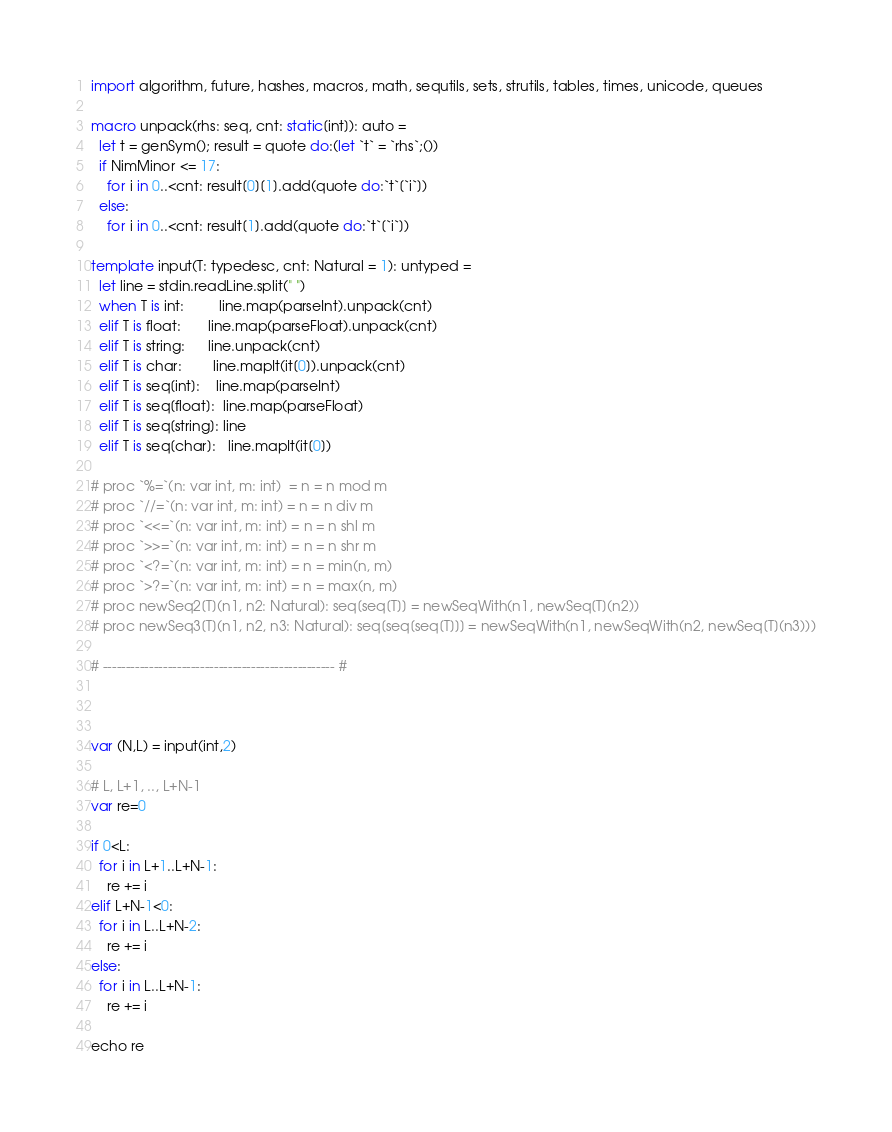Convert code to text. <code><loc_0><loc_0><loc_500><loc_500><_Nim_>import algorithm, future, hashes, macros, math, sequtils, sets, strutils, tables, times, unicode, queues
 
macro unpack(rhs: seq, cnt: static[int]): auto =
  let t = genSym(); result = quote do:(let `t` = `rhs`;())
  if NimMinor <= 17:
    for i in 0..<cnt: result[0][1].add(quote do:`t`[`i`])
  else:
    for i in 0..<cnt: result[1].add(quote do:`t`[`i`])
 
template input(T: typedesc, cnt: Natural = 1): untyped =
  let line = stdin.readLine.split(" ")
  when T is int:         line.map(parseInt).unpack(cnt)
  elif T is float:       line.map(parseFloat).unpack(cnt)
  elif T is string:      line.unpack(cnt)
  elif T is char:        line.mapIt(it[0]).unpack(cnt)
  elif T is seq[int]:    line.map(parseInt)
  elif T is seq[float]:  line.map(parseFloat)
  elif T is seq[string]: line
  elif T is seq[char]:   line.mapIt(it[0])
 
# proc `%=`(n: var int, m: int)  = n = n mod m
# proc `//=`(n: var int, m: int) = n = n div m
# proc `<<=`(n: var int, m: int) = n = n shl m
# proc `>>=`(n: var int, m: int) = n = n shr m
# proc `<?=`(n: var int, m: int) = n = min(n, m)
# proc `>?=`(n: var int, m: int) = n = max(n, m)
# proc newSeq2[T](n1, n2: Natural): seq[seq[T]] = newSeqWith(n1, newSeq[T](n2))
# proc newSeq3[T](n1, n2, n3: Natural): seq[seq[seq[T]]] = newSeqWith(n1, newSeqWith(n2, newSeq[T](n3)))
 
# -------------------------------------------------- #



var (N,L) = input(int,2)

# L, L+1, .., L+N-1
var re=0

if 0<L:
  for i in L+1..L+N-1:
    re += i
elif L+N-1<0:
  for i in L..L+N-2:
    re += i
else:
  for i in L..L+N-1:
    re += i

echo re</code> 